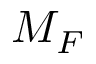Convert formula to latex. <formula><loc_0><loc_0><loc_500><loc_500>M _ { F }</formula> 